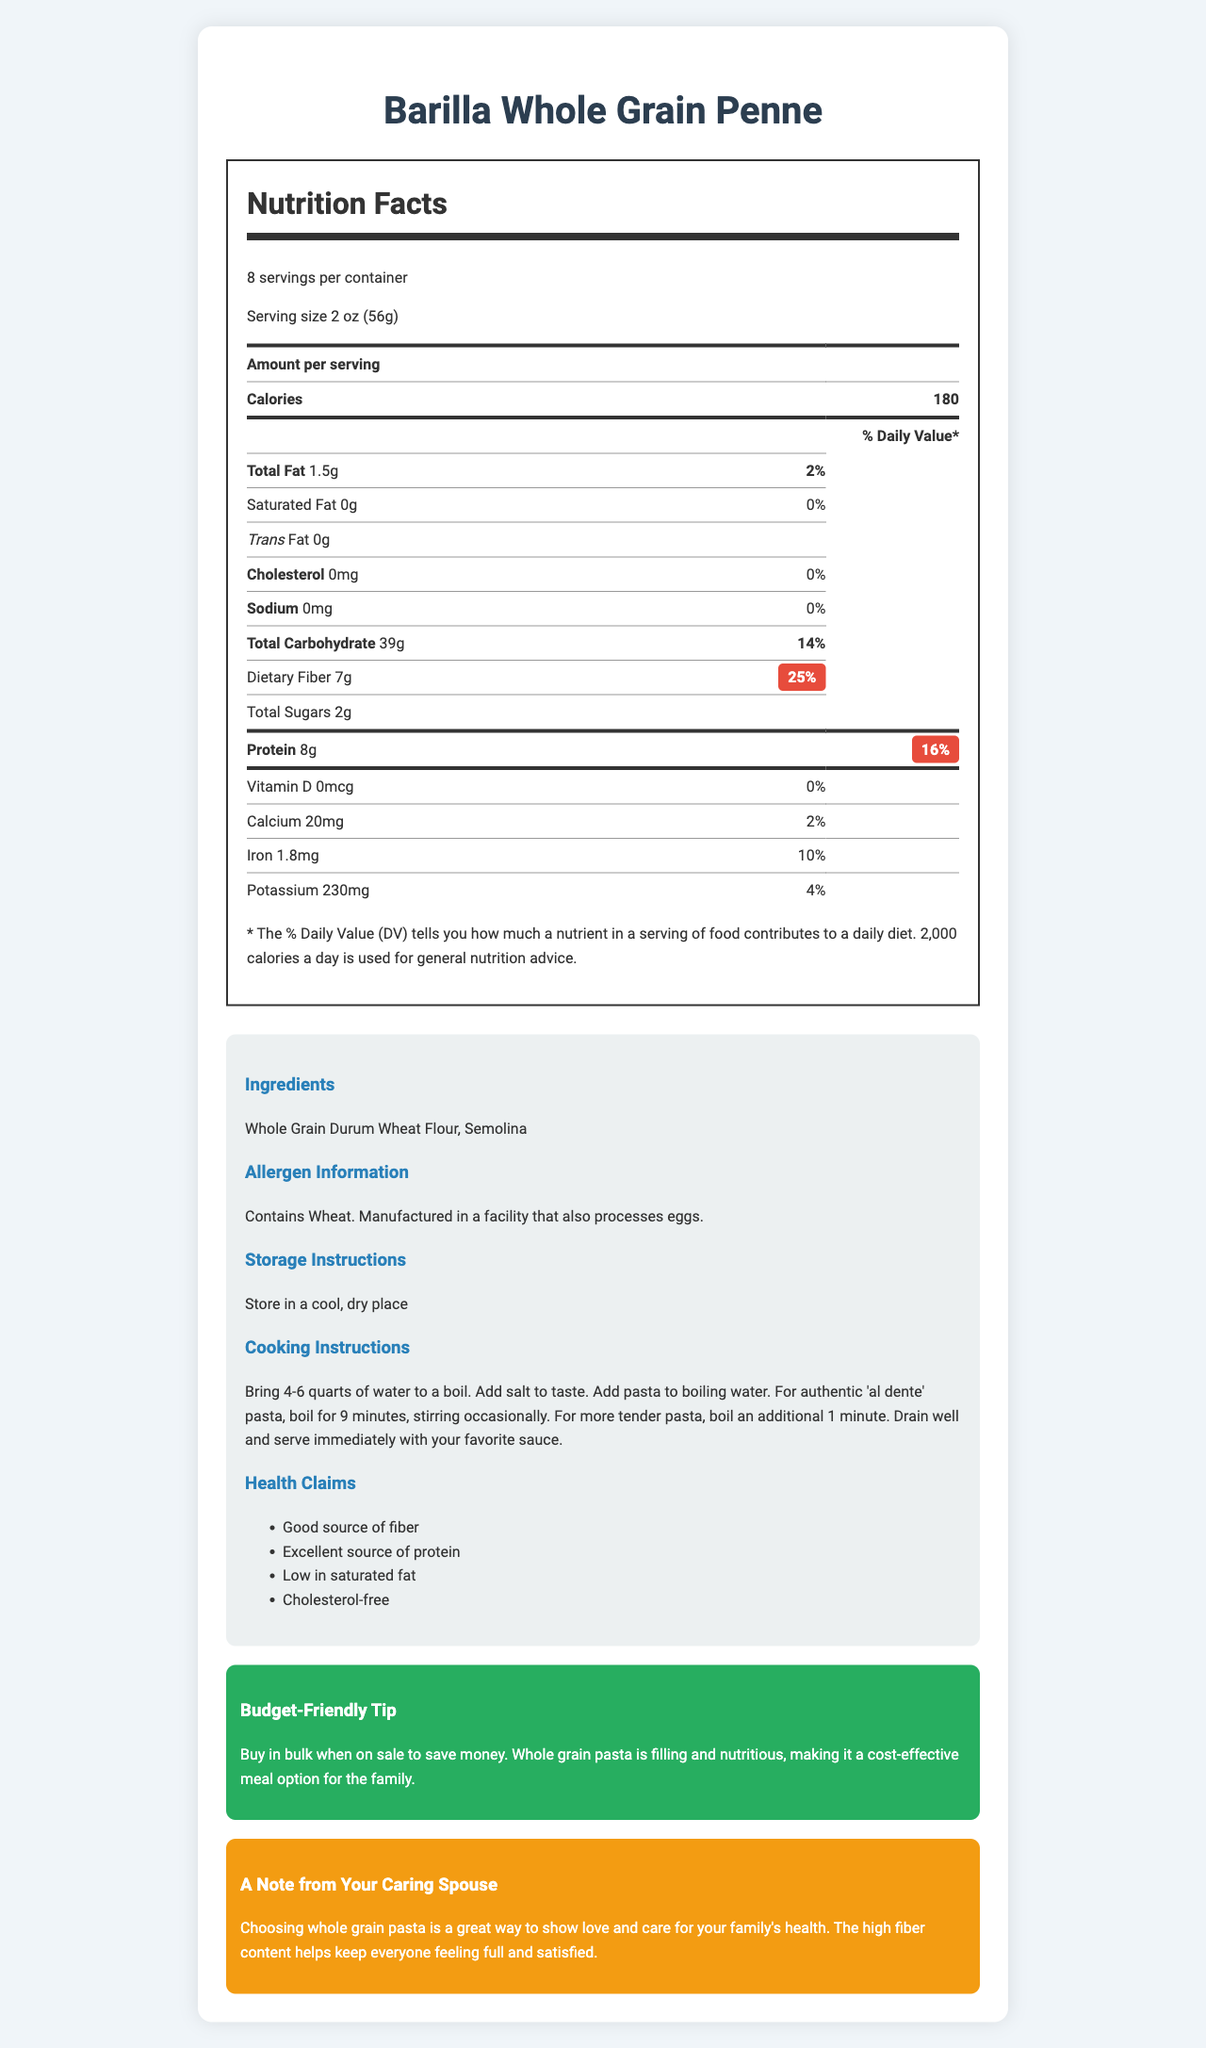what is the serving size for Barilla Whole Grain Penne? The serving size is mentioned at the beginning of the Nutrition Facts section.
Answer: 2 oz (56g) how many servings are there per container? The label mentions that there are 8 servings per container.
Answer: 8 how much dietary fiber is in one serving? According to the nutrition facts, one serving contains 7g of dietary fiber.
Answer: 7g what is the daily value percentage for protein? The daily value percentage for protein is listed as 16% in the nutrition facts section.
Answer: 16% which ingredient is listed in the allergen information? The allergen information specifies "Contains Wheat."
Answer: Wheat how many calories are in a serving? The nutrition facts state that each serving contains 180 calories.
Answer: 180 What is the daily value percentage of dietary fiber? A. 10% B. 25% C. 50% D. 75% The daily value percentage for dietary fiber is listed as 25%.
Answer: B Which nutrient is NOT listed in the nutrition facts? A. Vitamin C B. Iron C. Calcium D. Potassium The label lists Iron, Calcium, and Potassium but not Vitamin C.
Answer: A Is the pasta high in protein? The label describes it as an "Excellent source of protein," and the daily value is 16%, which is relatively high.
Answer: Yes Summarize the main idea of the document. The document presents a comprehensive overview of the nutritional content, preparation, and benefits of the whole grain pasta, focusing on fiber and protein content to support family health and budget-friendly meal planning.
Answer: The document provides detailed nutrition information for Barilla Whole Grain Penne, highlighting its serving size, calories, macronutrient content, vitamins, minerals, ingredients, allergen information, storage and cooking instructions, health claims, budget tips, and an emotional support note emphasizing the health benefits and care for the family. how much iron is in one serving? The nutrition facts list 1.8mg of iron per serving.
Answer: 1.8mg what does the budget-friendly tip suggest? The budget-friendly tip encourages buying in bulk to save money, suggesting that whole-grain pasta is a nutritious and economical meal choice.
Answer: Buy in bulk when on sale to save money. Whole grain pasta is filling and nutritious, making it a cost-effective meal option for the family. Can you determine the exact amount of trans fat in a serving of this pasta? The nutrition label specifies that the pasta contains 0g of trans fat per serving.
Answer: 0g What is the main ingredient of Barilla Whole Grain Penne? The ingredients list mentions "Whole Grain Durum Wheat Flour" as the main component.
Answer: Whole Grain Durum Wheat Flour Can you confirm if the product contains Vitamin D? The nutrition label indicates that there is 0mcg of Vitamin D, which is 0% of the daily value.
Answer: Yes What other food products are processed in the same facility? The allergen information notes that the product is manufactured in a facility that also processes eggs.
Answer: eggs are there any comments about the taste in the product description? The document does not contain any comments about the taste of the product.
Answer: No What are the health claims made about this product? The health claims section lists these specific claims about the product's nutritional benefits.
Answer: Good source of fiber, Excellent source of protein, Low in saturated fat, Cholesterol-free 